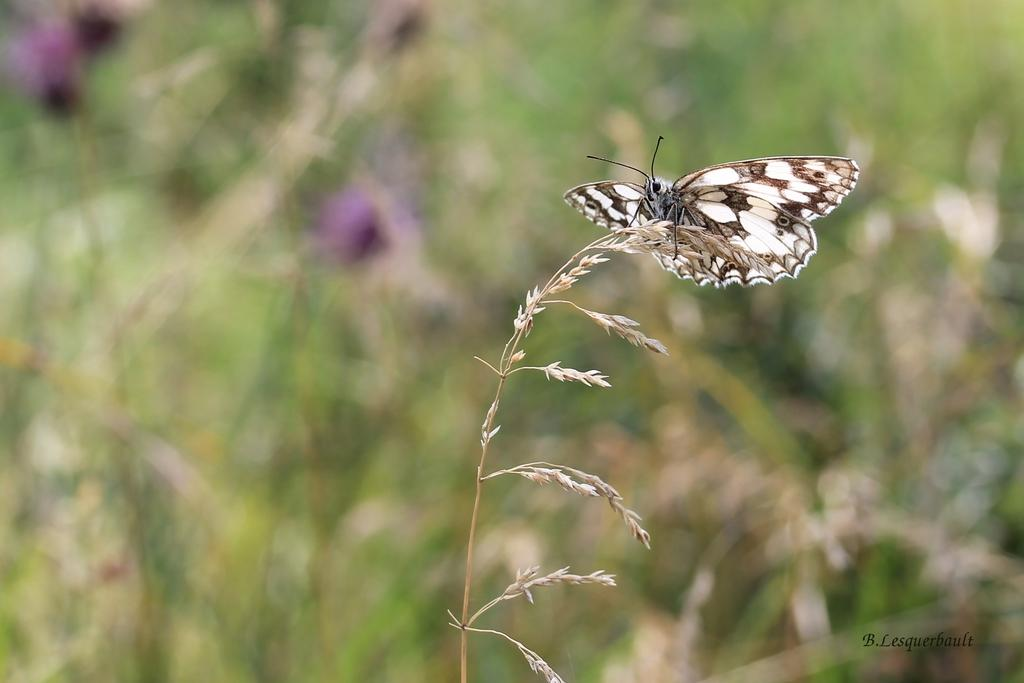What is on the plant in the image? There is a butterfly on a plant in the image. What can be observed about the background of the image? The background of the image is blurry. What size of stamp is on the butterfly in the image? There is no stamp present on the butterfly in the image. What type of machine can be seen in the background of the image? There is no machine visible in the image; the background is blurry. 